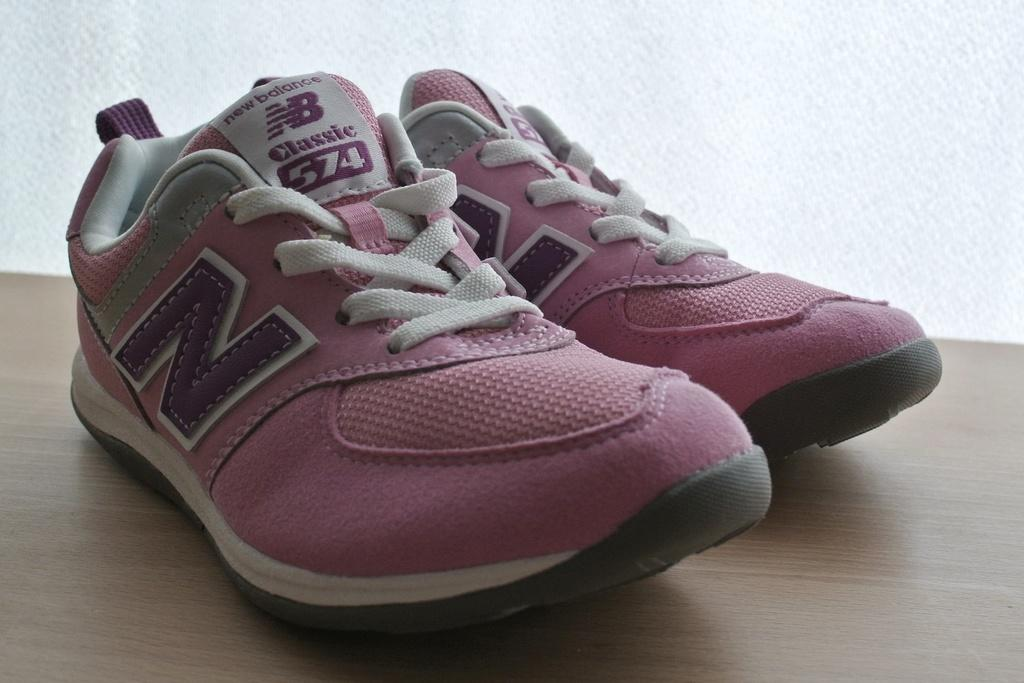What is placed on the table in the image? There is a pair of shoes on a table. What can be seen in the background of the image? There is a wall in the image. What type of wine is being served at the dinosaur-themed airport in the image? There is no wine, dinosaur, or airport present in the image; it only features a pair of shoes on a table and a wall in the background. 